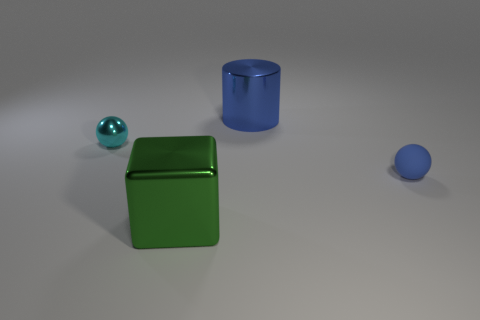Add 4 small rubber spheres. How many objects exist? 8 Subtract all cylinders. How many objects are left? 3 Add 4 small yellow cylinders. How many small yellow cylinders exist? 4 Subtract 0 gray cubes. How many objects are left? 4 Subtract all balls. Subtract all red metal things. How many objects are left? 2 Add 2 small metallic things. How many small metallic things are left? 3 